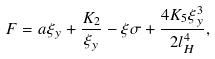Convert formula to latex. <formula><loc_0><loc_0><loc_500><loc_500>F = a \xi _ { y } + \frac { K _ { 2 } } { \xi _ { y } } - \xi \sigma + \frac { 4 K _ { 5 } \xi _ { y } ^ { 3 } } { 2 l _ { H } ^ { 4 } } ,</formula> 